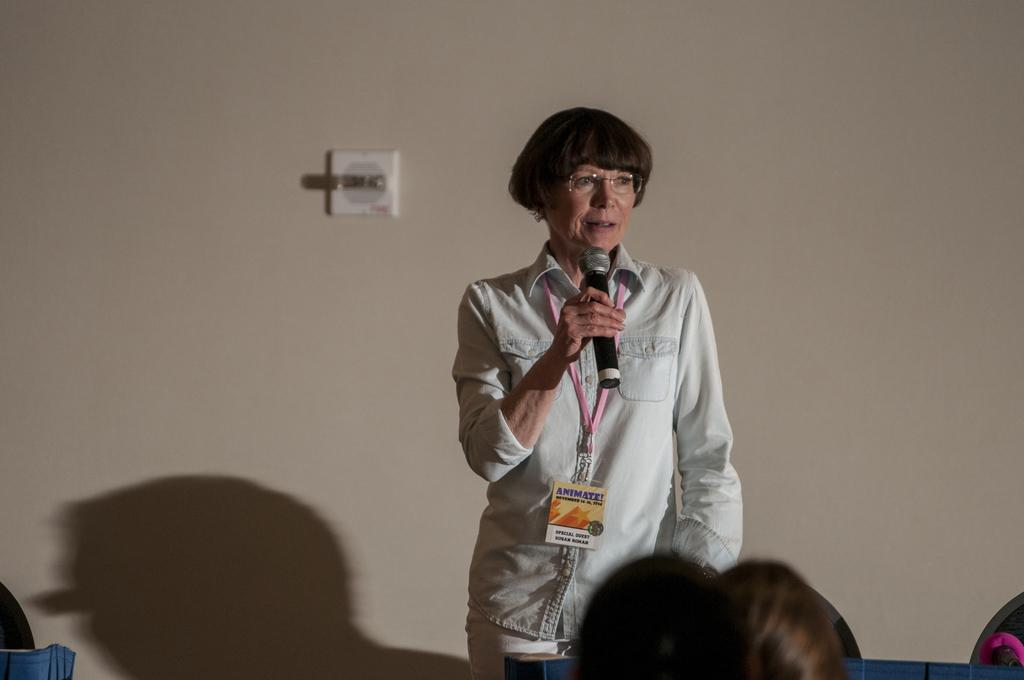What is the person in the image wearing on their upper body? The person in the image is wearing a shirt. What accessory is the person wearing on their face? The person is wearing spectacles. What object is the person holding in their right hand? The person is holding a microphone in their right hand. What can be seen behind the person? There is a wall behind the person. What is in front of the person? There are people in front of the person. What type of clouds can be seen in the image? There are no clouds visible in the image; it features a person holding a microphone with people in front of them. 